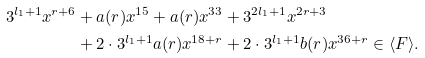<formula> <loc_0><loc_0><loc_500><loc_500>3 ^ { l _ { 1 } + 1 } x ^ { r + 6 } & + a ( r ) x ^ { 1 5 } + a ( r ) x ^ { 3 3 } + 3 ^ { 2 l _ { 1 } + 1 } x ^ { 2 r + 3 } \\ & + 2 \cdot 3 ^ { l _ { 1 } + 1 } a ( r ) x ^ { 1 8 + r } + 2 \cdot 3 ^ { l _ { 1 } + 1 } b ( r ) x ^ { 3 6 + r } \in \langle F \rangle .</formula> 